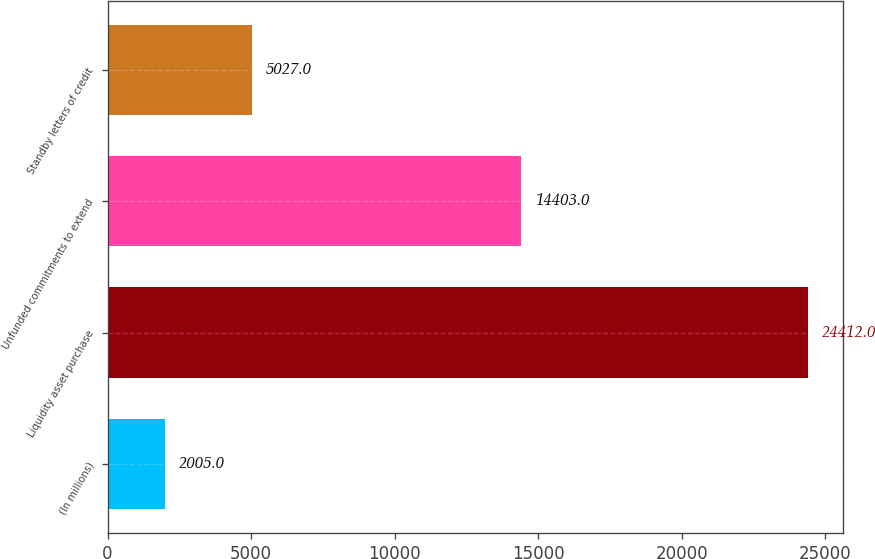Convert chart. <chart><loc_0><loc_0><loc_500><loc_500><bar_chart><fcel>(In millions)<fcel>Liquidity asset purchase<fcel>Unfunded commitments to extend<fcel>Standby letters of credit<nl><fcel>2005<fcel>24412<fcel>14403<fcel>5027<nl></chart> 